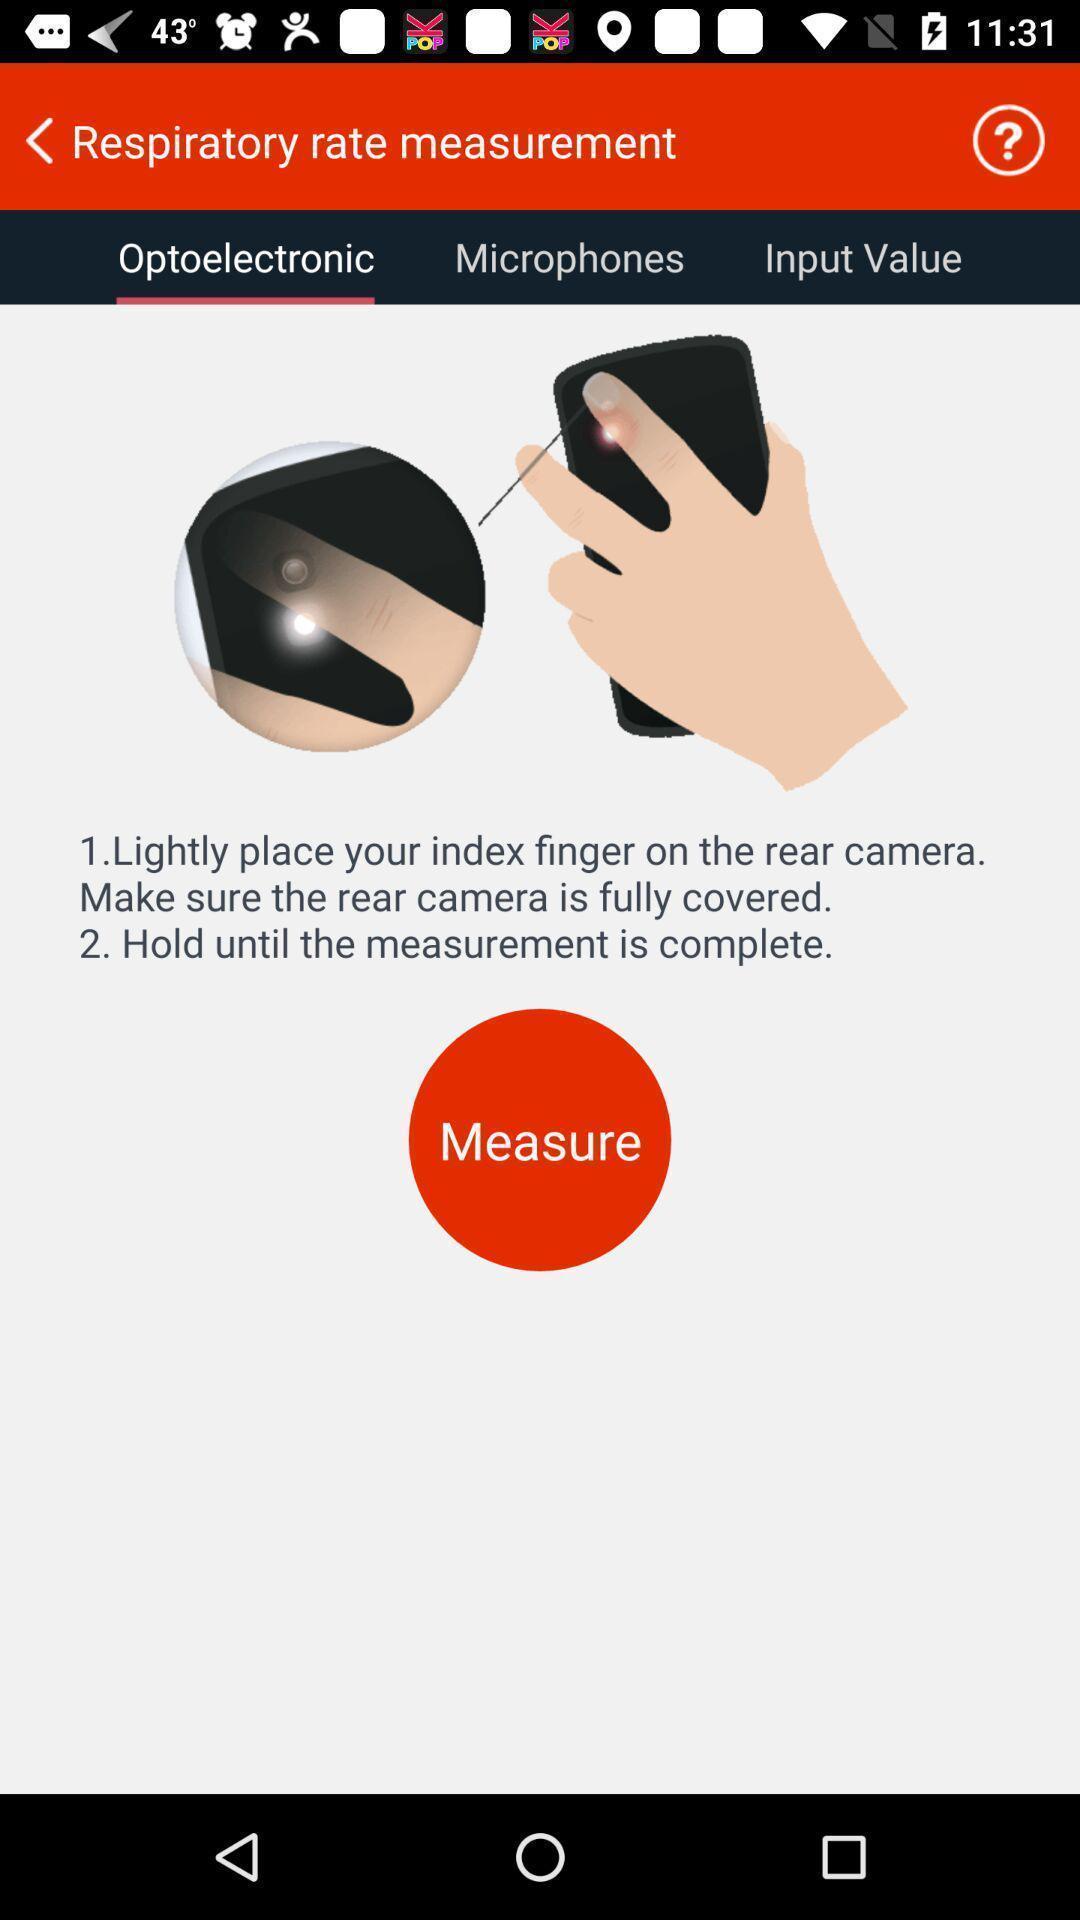Describe this image in words. Page showing a measure button. 